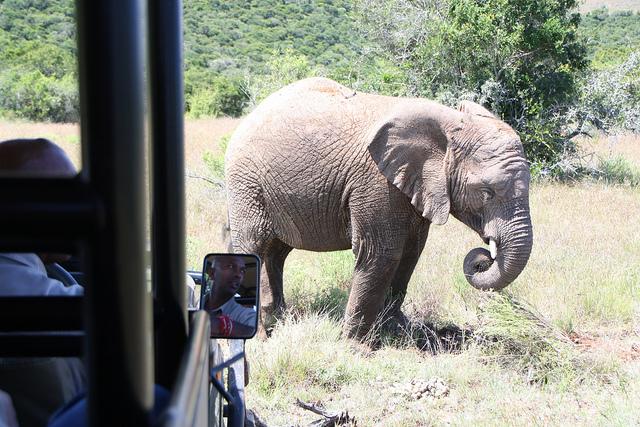Does the elephant seem to notice the vehicle?
Write a very short answer. No. Is the elephant sleeping?
Keep it brief. No. Is there a man in the rear-view mirror?
Be succinct. Yes. 